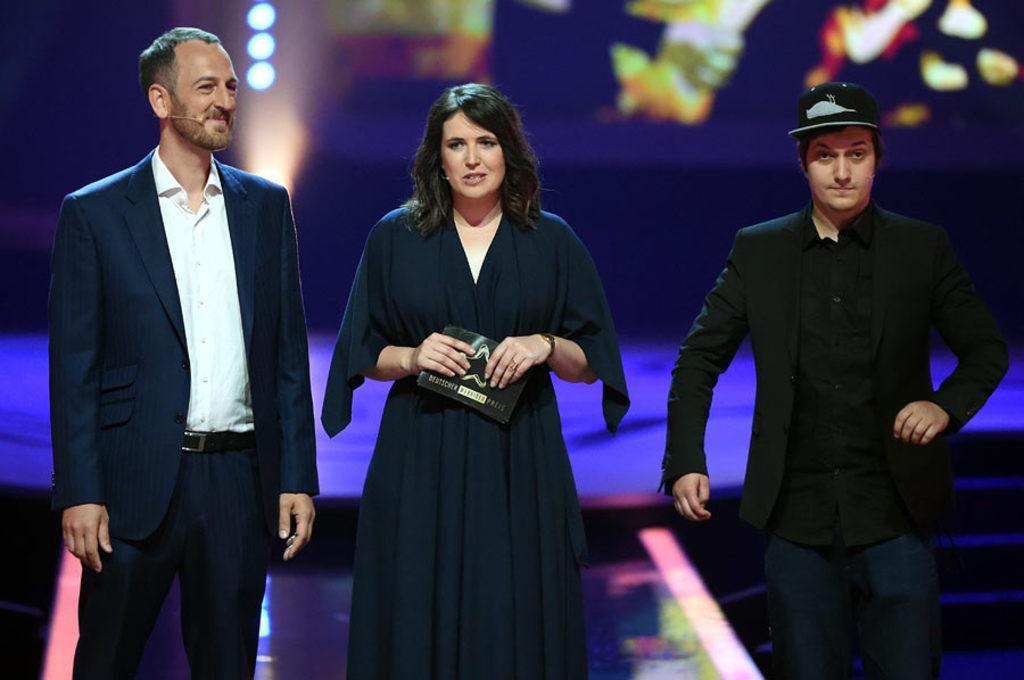Describe this image in one or two sentences. In this image there are two men and a woman standing on the dais. In the center a woman and she is holding a paper in her hand. To the right there is a man standing and he is wearing a cap. The background is blurry. 